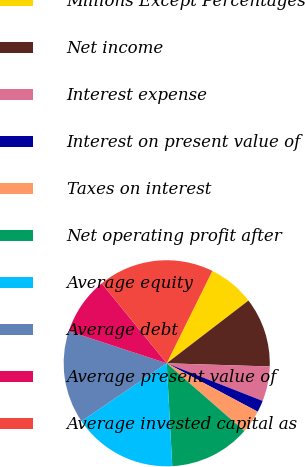Convert chart. <chart><loc_0><loc_0><loc_500><loc_500><pie_chart><fcel>Millions Except Percentages<fcel>Net income<fcel>Interest expense<fcel>Interest on present value of<fcel>Taxes on interest<fcel>Net operating profit after<fcel>Average equity<fcel>Average debt<fcel>Average present value of<fcel>Average invested capital as<nl><fcel>7.28%<fcel>10.91%<fcel>5.46%<fcel>1.83%<fcel>3.64%<fcel>12.72%<fcel>16.36%<fcel>14.54%<fcel>9.09%<fcel>18.17%<nl></chart> 